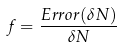Convert formula to latex. <formula><loc_0><loc_0><loc_500><loc_500>f = \frac { E r r o r ( \delta N ) } { \delta N }</formula> 